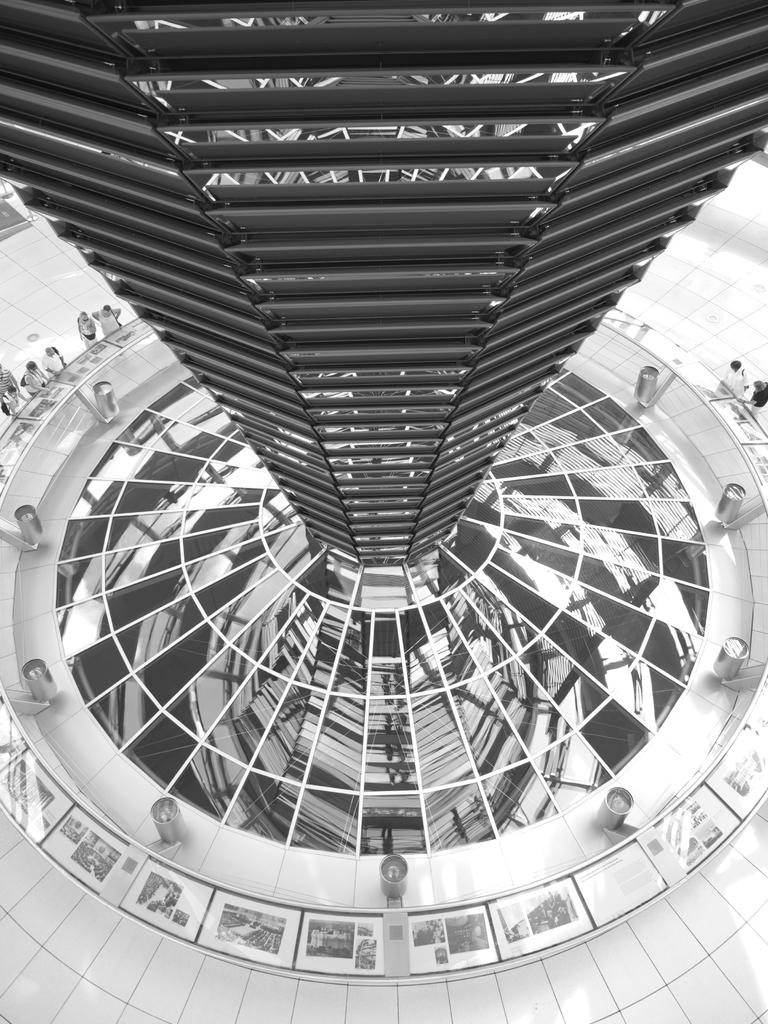What is the color scheme of the image? The image is black and white. What type of structure can be seen in the image? There is a structure with rods and glass in the image. Are there any people present in the image? Yes, there are people in the image. What is visible at the bottom of the image? There is a floor visible at the bottom of the image. Can you tell me how many parcels are being delivered by the maid in the image? There is no maid or parcel present in the image. What type of bulb is used to light up the structure in the image? There is no information about the type of bulb used in the image, as it is a black and white image. 